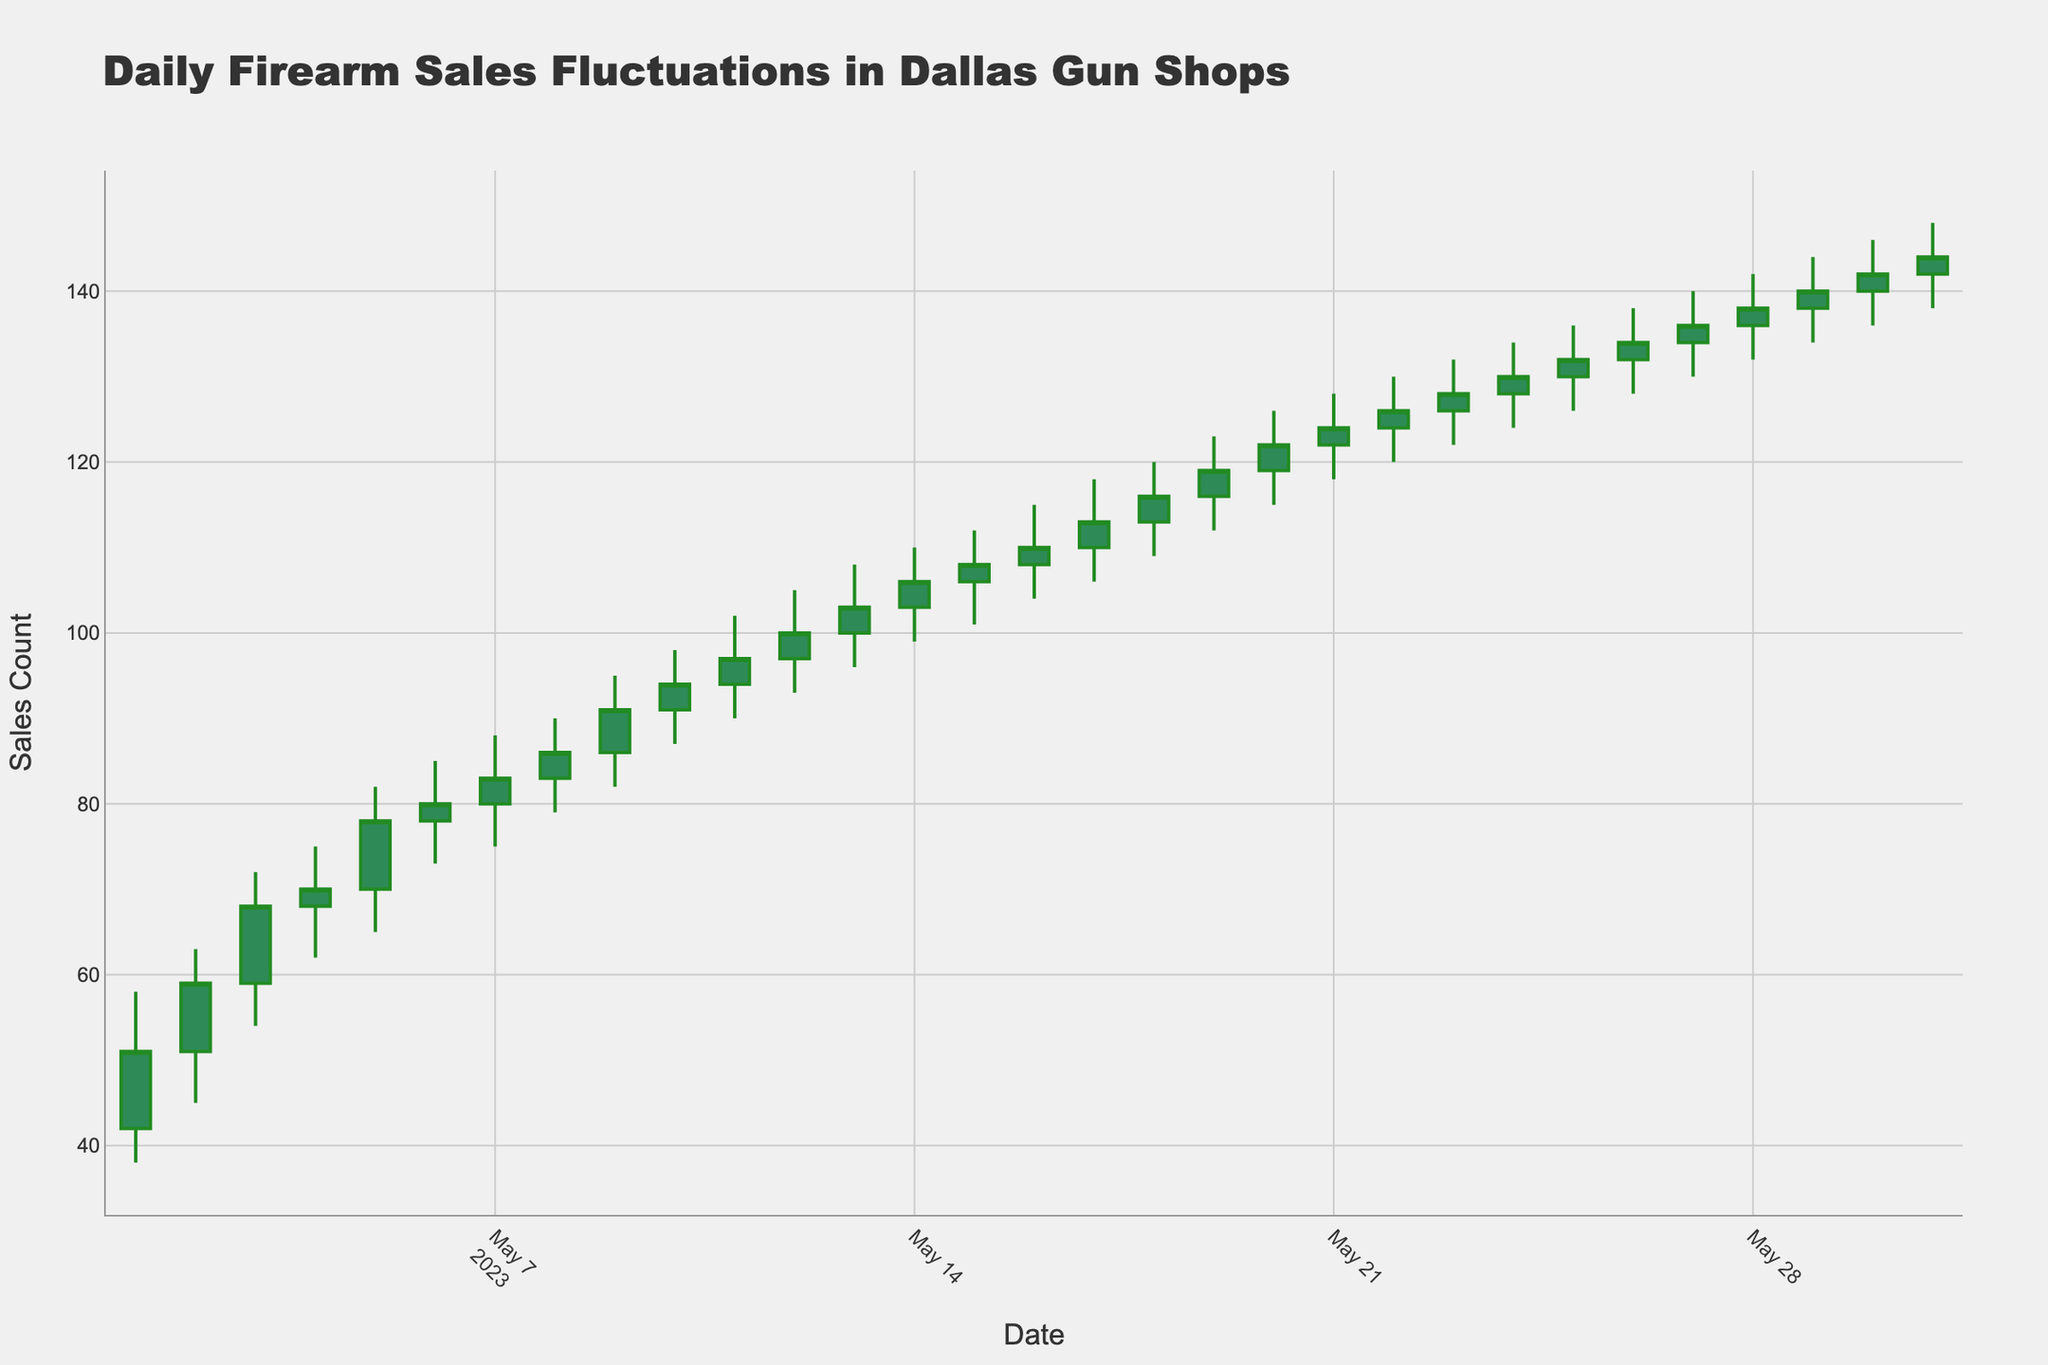What is the title of the chart? The title is clearly visible at the top of the chart, which is "Daily Firearm Sales Fluctuations in Dallas Gun Shops".
Answer: Daily Firearm Sales Fluctuations in Dallas Gun Shops How many days are represented in the chart? Each candlestick in the chart represents one day, counting the candlesticks or referring to the x-axis from May 1 to May 31, we can determine it.
Answer: 31 What was the highest sales count on any given day? To find the highest sales count on any given day, we need to look at the highest value of the 'High' points in the chart, which shows 148 on May 31.
Answer: 148 On which day did firearm sales close at their lowest value? To find the day with the lowest closing value, refer to the 'Close' value at the bottom of each candlestick. The lowest closing value is 51 on May 1.
Answer: May 1 How many days did the sales close higher than they opened? Observing each candlestick where the top of the candlestick body (Close) is higher than the bottom (Open). All days clearly show this upward trend.
Answer: 31 Compare sales on May 10 and May 20. Which day had a higher opening value? To compare the open values, we look at the 'Open' price for both days. On May 10, the open value was 91, and on May 20, it was 119.
Answer: May 20 What was the average closing sales count over the first 7 days? Summing the close values from May 1 to May 7 (51 + 59 + 68 + 70 + 78 + 80 + 83) gives 489. Dividing by 7 gives an average of \( \frac{489}{7} = 69.86 \).
Answer: 69.86 What was the smallest range (High-Low) in firearm sales on a single day, and on which day did it occur? By calculating the range (High - Low) for each day and finding the minimum value, we see on May 4, the range is (75 - 62) = 13, which is the smallest.
Answer: 13 on May 4 Did firearm sales ever decrease over three consecutive days? To identify this, we look for three consecutive candlesticks where the 'Close' value decreases each day. Such pattern is not found in the dataset.
Answer: No What is the longest upward trend (continuously increasing 'Close' values) shown in the chart? Observing the 'Close' values, the longest upward trend appears from May 1 to May 14, a total of 14 consecutive days with increasing close values.
Answer: 14 days (May 1 to May 14) 